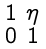Convert formula to latex. <formula><loc_0><loc_0><loc_500><loc_500>\begin{smallmatrix} 1 & \eta \\ 0 & 1 \end{smallmatrix}</formula> 